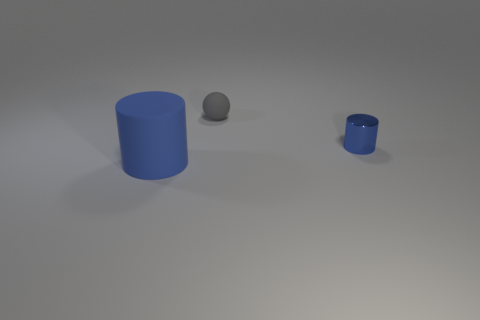What materials do the objects in the image appear to be made of? The objects in the image appear to be made of different materials. The larger cylinder has a matte finish suggesting a non-metallic, possibly plastic material. The smaller cylinder and the sphere have metallic finishes, indicating they could be made of metal. 